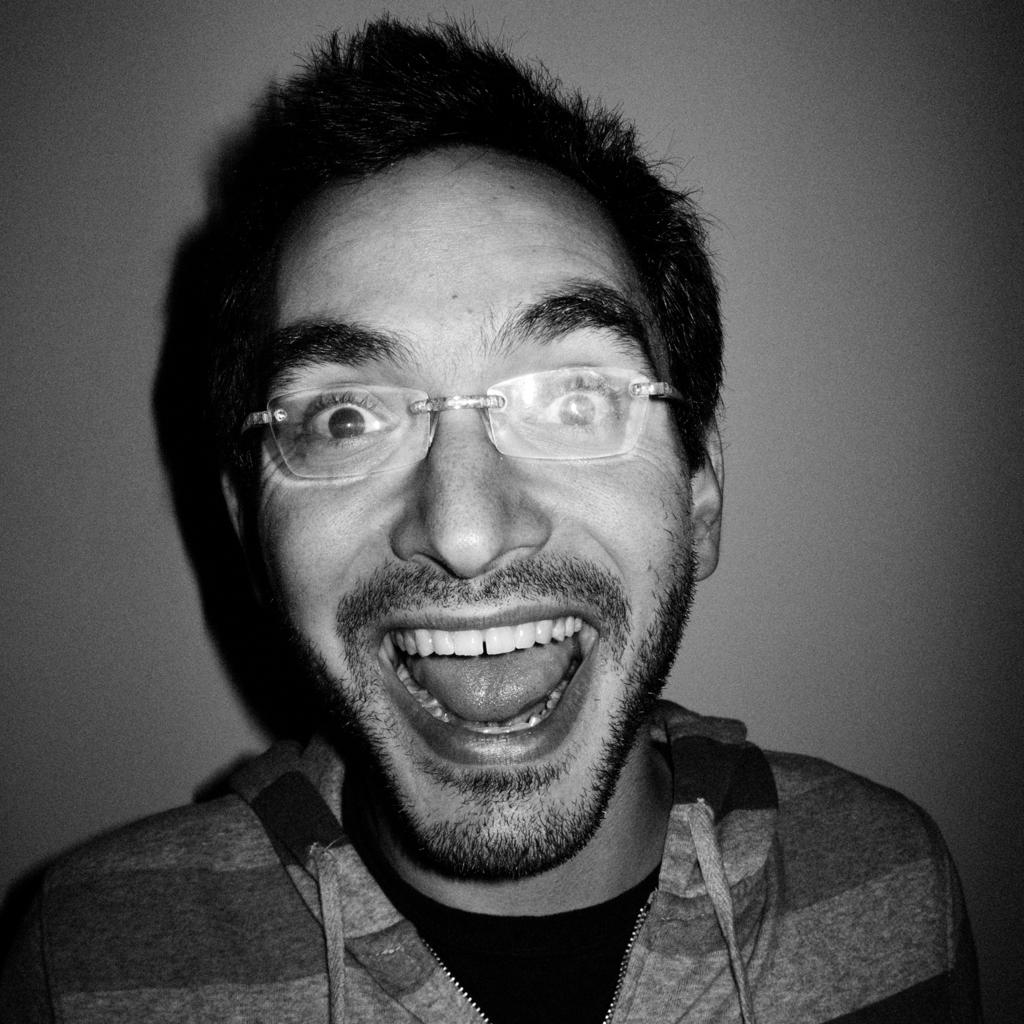What is present in the image? There is a man in the image. Can you describe the man's appearance? The man is wearing spectacles and a jacket. What is visible in the background of the image? There is a wall visible behind the man in the image. What type of belief system does the man in the image follow? There is no information about the man's belief system in the image. Can you tell me how many planes are visible in the image? There are no planes present in the image. 